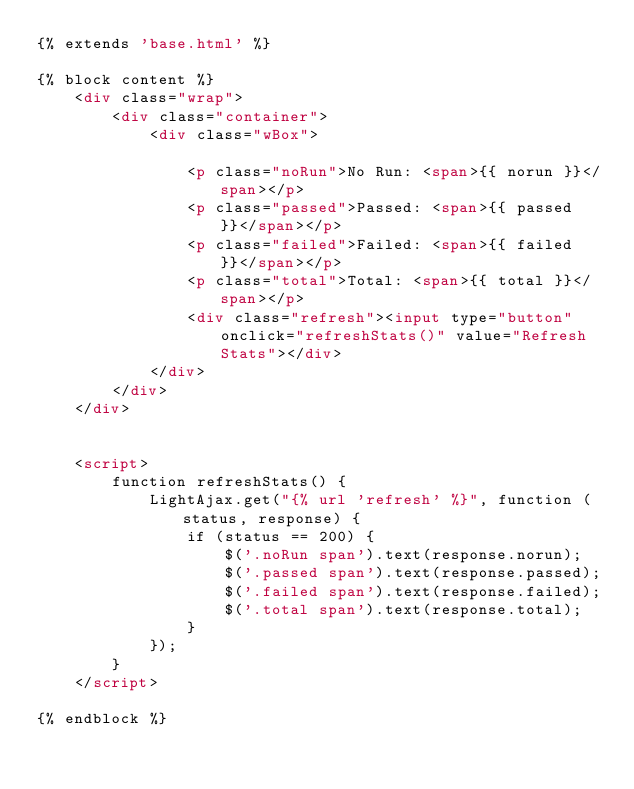Convert code to text. <code><loc_0><loc_0><loc_500><loc_500><_HTML_>{% extends 'base.html' %}

{% block content %}
    <div class="wrap">
        <div class="container">
            <div class="wBox">

                <p class="noRun">No Run: <span>{{ norun }}</span></p>
                <p class="passed">Passed: <span>{{ passed }}</span></p>
                <p class="failed">Failed: <span>{{ failed }}</span></p>
                <p class="total">Total: <span>{{ total }}</span></p>
                <div class="refresh"><input type="button" onclick="refreshStats()" value="Refresh Stats"></div>
            </div>
        </div>
    </div>


    <script>
        function refreshStats() {
            LightAjax.get("{% url 'refresh' %}", function (status, response) {
                if (status == 200) {
                    $('.noRun span').text(response.norun);
                    $('.passed span').text(response.passed);
                    $('.failed span').text(response.failed);
                    $('.total span').text(response.total);
                }
            });
        }
    </script>

{% endblock %}
</code> 